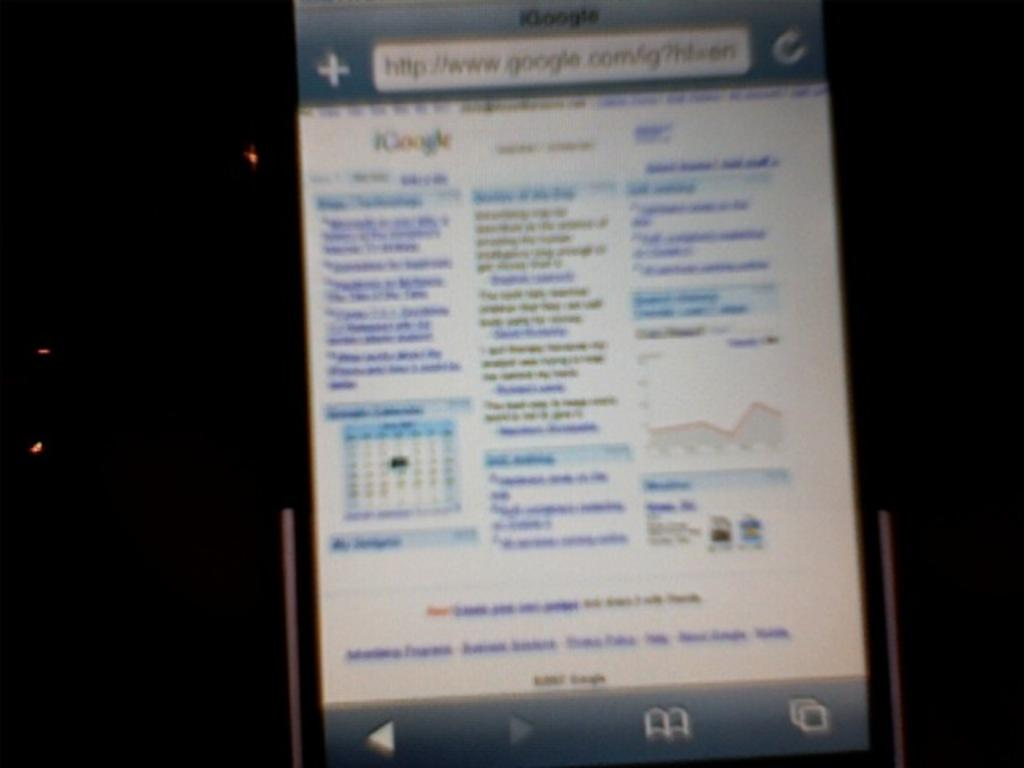What is the main object in the image? There is a screen in the image. What can be seen on the screen? Text is visible on the screen. How would you describe the overall lighting in the image? The background of the image is dark, but there are lights visible. How many icicles are hanging from the screen in the image? There are no icicles present in the image. What stage of development is the attention in the image? The image does not depict any development or attention; it only shows a screen with text and a dark background with lights. 